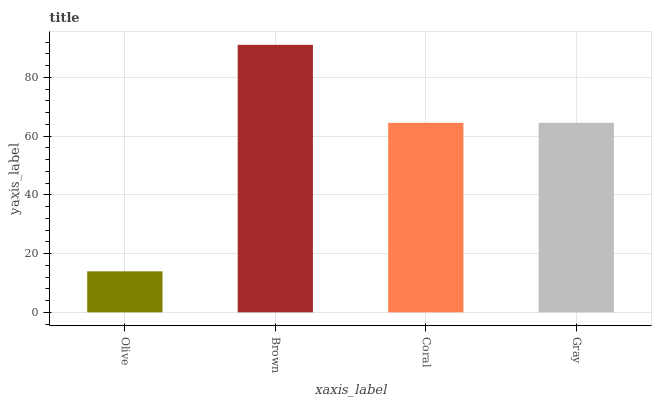Is Olive the minimum?
Answer yes or no. Yes. Is Brown the maximum?
Answer yes or no. Yes. Is Coral the minimum?
Answer yes or no. No. Is Coral the maximum?
Answer yes or no. No. Is Brown greater than Coral?
Answer yes or no. Yes. Is Coral less than Brown?
Answer yes or no. Yes. Is Coral greater than Brown?
Answer yes or no. No. Is Brown less than Coral?
Answer yes or no. No. Is Gray the high median?
Answer yes or no. Yes. Is Coral the low median?
Answer yes or no. Yes. Is Brown the high median?
Answer yes or no. No. Is Olive the low median?
Answer yes or no. No. 